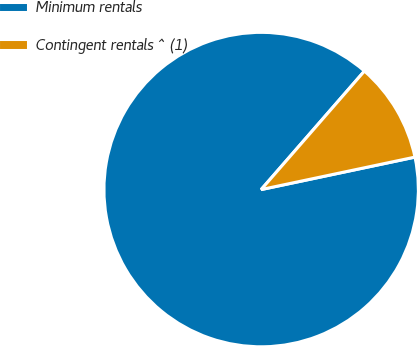Convert chart to OTSL. <chart><loc_0><loc_0><loc_500><loc_500><pie_chart><fcel>Minimum rentals<fcel>Contingent rentals ^ (1)<nl><fcel>89.72%<fcel>10.28%<nl></chart> 